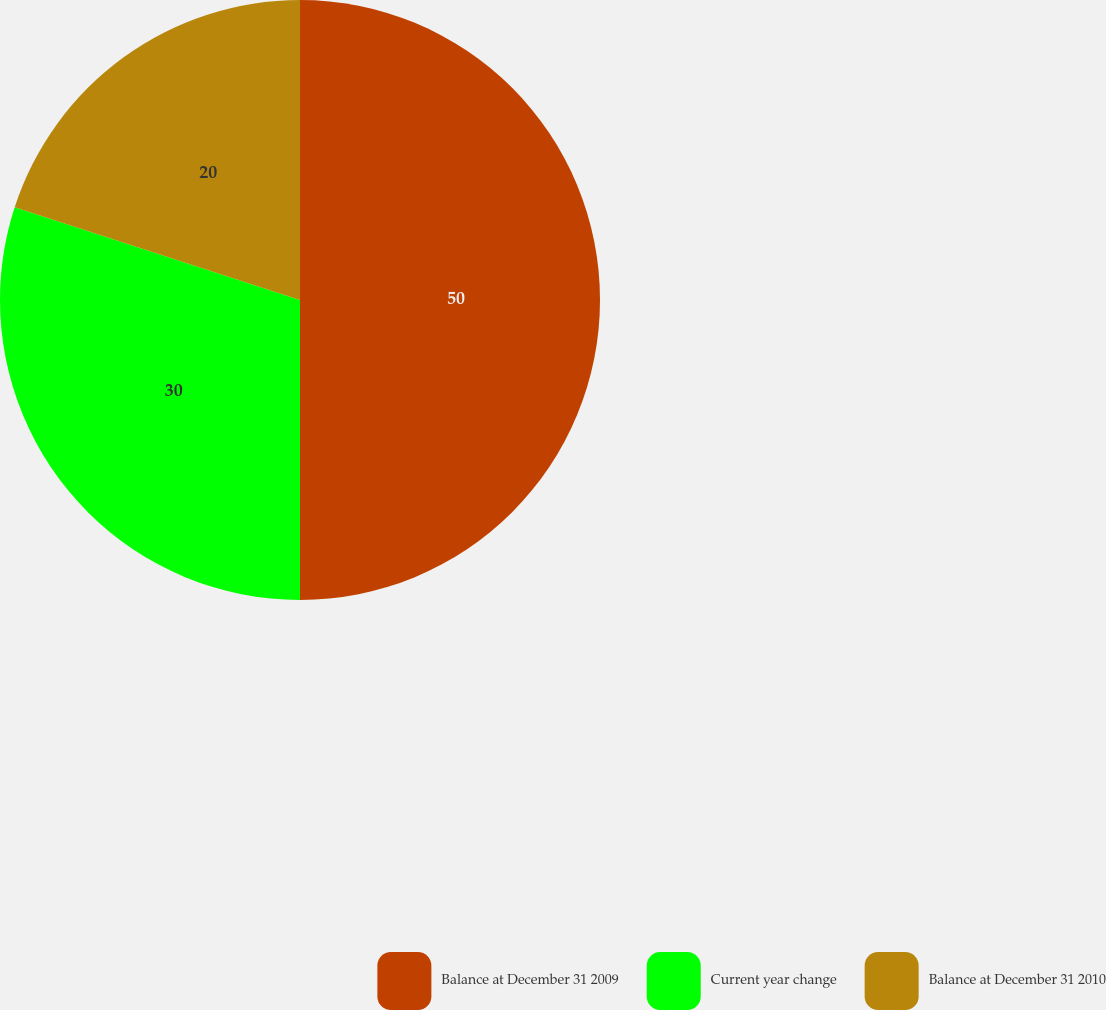Convert chart to OTSL. <chart><loc_0><loc_0><loc_500><loc_500><pie_chart><fcel>Balance at December 31 2009<fcel>Current year change<fcel>Balance at December 31 2010<nl><fcel>50.0%<fcel>30.0%<fcel>20.0%<nl></chart> 